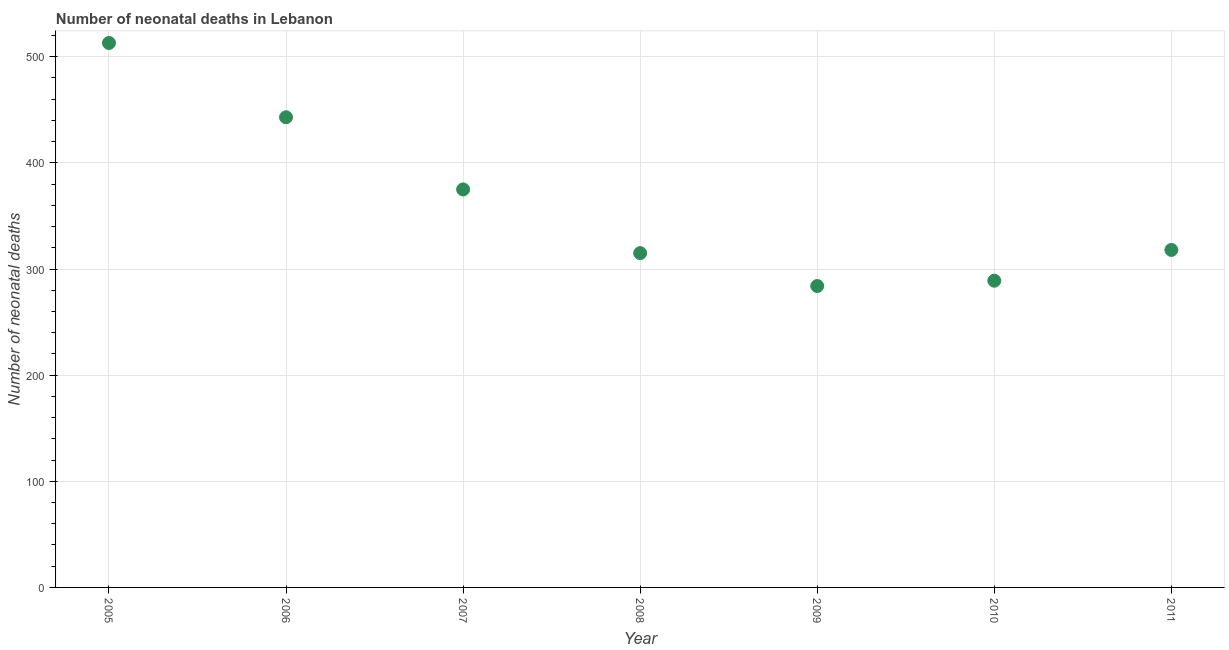What is the number of neonatal deaths in 2009?
Give a very brief answer. 284. Across all years, what is the maximum number of neonatal deaths?
Offer a terse response. 513. Across all years, what is the minimum number of neonatal deaths?
Your response must be concise. 284. In which year was the number of neonatal deaths minimum?
Your answer should be very brief. 2009. What is the sum of the number of neonatal deaths?
Give a very brief answer. 2537. What is the difference between the number of neonatal deaths in 2007 and 2009?
Provide a succinct answer. 91. What is the average number of neonatal deaths per year?
Keep it short and to the point. 362.43. What is the median number of neonatal deaths?
Provide a short and direct response. 318. In how many years, is the number of neonatal deaths greater than 240 ?
Offer a very short reply. 7. Do a majority of the years between 2009 and 2006 (inclusive) have number of neonatal deaths greater than 100 ?
Make the answer very short. Yes. What is the ratio of the number of neonatal deaths in 2005 to that in 2008?
Your answer should be compact. 1.63. Is the sum of the number of neonatal deaths in 2007 and 2009 greater than the maximum number of neonatal deaths across all years?
Your response must be concise. Yes. What is the difference between the highest and the lowest number of neonatal deaths?
Your answer should be compact. 229. In how many years, is the number of neonatal deaths greater than the average number of neonatal deaths taken over all years?
Keep it short and to the point. 3. How many dotlines are there?
Your answer should be compact. 1. What is the difference between two consecutive major ticks on the Y-axis?
Your answer should be very brief. 100. Are the values on the major ticks of Y-axis written in scientific E-notation?
Give a very brief answer. No. Does the graph contain grids?
Give a very brief answer. Yes. What is the title of the graph?
Provide a short and direct response. Number of neonatal deaths in Lebanon. What is the label or title of the Y-axis?
Offer a terse response. Number of neonatal deaths. What is the Number of neonatal deaths in 2005?
Your response must be concise. 513. What is the Number of neonatal deaths in 2006?
Make the answer very short. 443. What is the Number of neonatal deaths in 2007?
Make the answer very short. 375. What is the Number of neonatal deaths in 2008?
Offer a terse response. 315. What is the Number of neonatal deaths in 2009?
Keep it short and to the point. 284. What is the Number of neonatal deaths in 2010?
Offer a very short reply. 289. What is the Number of neonatal deaths in 2011?
Make the answer very short. 318. What is the difference between the Number of neonatal deaths in 2005 and 2006?
Keep it short and to the point. 70. What is the difference between the Number of neonatal deaths in 2005 and 2007?
Your answer should be very brief. 138. What is the difference between the Number of neonatal deaths in 2005 and 2008?
Provide a short and direct response. 198. What is the difference between the Number of neonatal deaths in 2005 and 2009?
Make the answer very short. 229. What is the difference between the Number of neonatal deaths in 2005 and 2010?
Your answer should be compact. 224. What is the difference between the Number of neonatal deaths in 2005 and 2011?
Provide a short and direct response. 195. What is the difference between the Number of neonatal deaths in 2006 and 2007?
Provide a succinct answer. 68. What is the difference between the Number of neonatal deaths in 2006 and 2008?
Ensure brevity in your answer.  128. What is the difference between the Number of neonatal deaths in 2006 and 2009?
Offer a terse response. 159. What is the difference between the Number of neonatal deaths in 2006 and 2010?
Make the answer very short. 154. What is the difference between the Number of neonatal deaths in 2006 and 2011?
Your response must be concise. 125. What is the difference between the Number of neonatal deaths in 2007 and 2008?
Offer a terse response. 60. What is the difference between the Number of neonatal deaths in 2007 and 2009?
Your answer should be compact. 91. What is the difference between the Number of neonatal deaths in 2007 and 2010?
Ensure brevity in your answer.  86. What is the difference between the Number of neonatal deaths in 2007 and 2011?
Make the answer very short. 57. What is the difference between the Number of neonatal deaths in 2008 and 2010?
Provide a succinct answer. 26. What is the difference between the Number of neonatal deaths in 2008 and 2011?
Make the answer very short. -3. What is the difference between the Number of neonatal deaths in 2009 and 2011?
Make the answer very short. -34. What is the ratio of the Number of neonatal deaths in 2005 to that in 2006?
Provide a short and direct response. 1.16. What is the ratio of the Number of neonatal deaths in 2005 to that in 2007?
Your answer should be compact. 1.37. What is the ratio of the Number of neonatal deaths in 2005 to that in 2008?
Provide a succinct answer. 1.63. What is the ratio of the Number of neonatal deaths in 2005 to that in 2009?
Make the answer very short. 1.81. What is the ratio of the Number of neonatal deaths in 2005 to that in 2010?
Make the answer very short. 1.77. What is the ratio of the Number of neonatal deaths in 2005 to that in 2011?
Keep it short and to the point. 1.61. What is the ratio of the Number of neonatal deaths in 2006 to that in 2007?
Your answer should be very brief. 1.18. What is the ratio of the Number of neonatal deaths in 2006 to that in 2008?
Provide a succinct answer. 1.41. What is the ratio of the Number of neonatal deaths in 2006 to that in 2009?
Offer a terse response. 1.56. What is the ratio of the Number of neonatal deaths in 2006 to that in 2010?
Your answer should be compact. 1.53. What is the ratio of the Number of neonatal deaths in 2006 to that in 2011?
Your answer should be compact. 1.39. What is the ratio of the Number of neonatal deaths in 2007 to that in 2008?
Your response must be concise. 1.19. What is the ratio of the Number of neonatal deaths in 2007 to that in 2009?
Give a very brief answer. 1.32. What is the ratio of the Number of neonatal deaths in 2007 to that in 2010?
Provide a short and direct response. 1.3. What is the ratio of the Number of neonatal deaths in 2007 to that in 2011?
Give a very brief answer. 1.18. What is the ratio of the Number of neonatal deaths in 2008 to that in 2009?
Provide a short and direct response. 1.11. What is the ratio of the Number of neonatal deaths in 2008 to that in 2010?
Your answer should be compact. 1.09. What is the ratio of the Number of neonatal deaths in 2009 to that in 2011?
Give a very brief answer. 0.89. What is the ratio of the Number of neonatal deaths in 2010 to that in 2011?
Your answer should be compact. 0.91. 